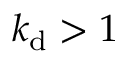Convert formula to latex. <formula><loc_0><loc_0><loc_500><loc_500>k _ { d } > 1</formula> 